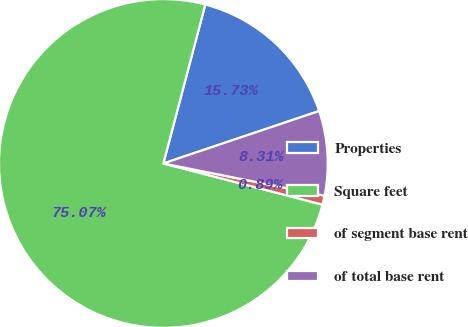<chart> <loc_0><loc_0><loc_500><loc_500><pie_chart><fcel>Properties<fcel>Square feet<fcel>of segment base rent<fcel>of total base rent<nl><fcel>15.73%<fcel>75.08%<fcel>0.89%<fcel>8.31%<nl></chart> 